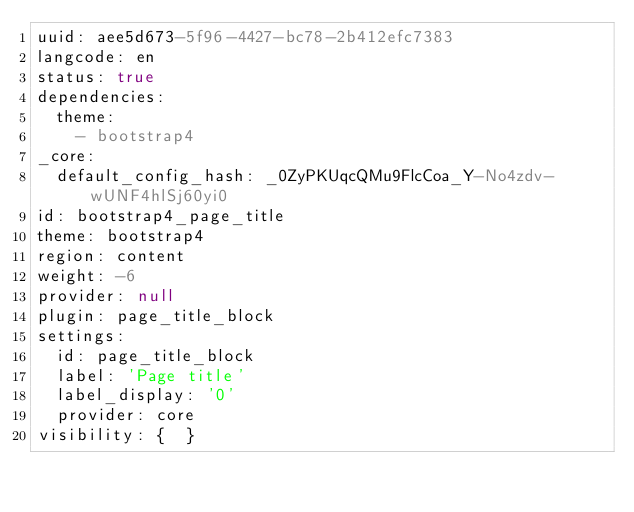Convert code to text. <code><loc_0><loc_0><loc_500><loc_500><_YAML_>uuid: aee5d673-5f96-4427-bc78-2b412efc7383
langcode: en
status: true
dependencies:
  theme:
    - bootstrap4
_core:
  default_config_hash: _0ZyPKUqcQMu9FlcCoa_Y-No4zdv-wUNF4hlSj60yi0
id: bootstrap4_page_title
theme: bootstrap4
region: content
weight: -6
provider: null
plugin: page_title_block
settings:
  id: page_title_block
  label: 'Page title'
  label_display: '0'
  provider: core
visibility: {  }
</code> 